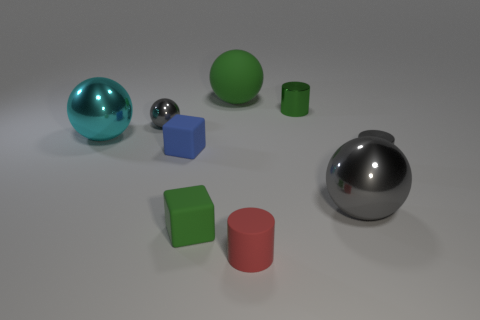Subtract all yellow spheres. Subtract all gray cylinders. How many spheres are left? 4 Subtract all cubes. How many objects are left? 7 Subtract all tiny gray cylinders. Subtract all cyan spheres. How many objects are left? 7 Add 5 tiny red rubber objects. How many tiny red rubber objects are left? 6 Add 8 big gray spheres. How many big gray spheres exist? 9 Subtract 1 gray cylinders. How many objects are left? 8 